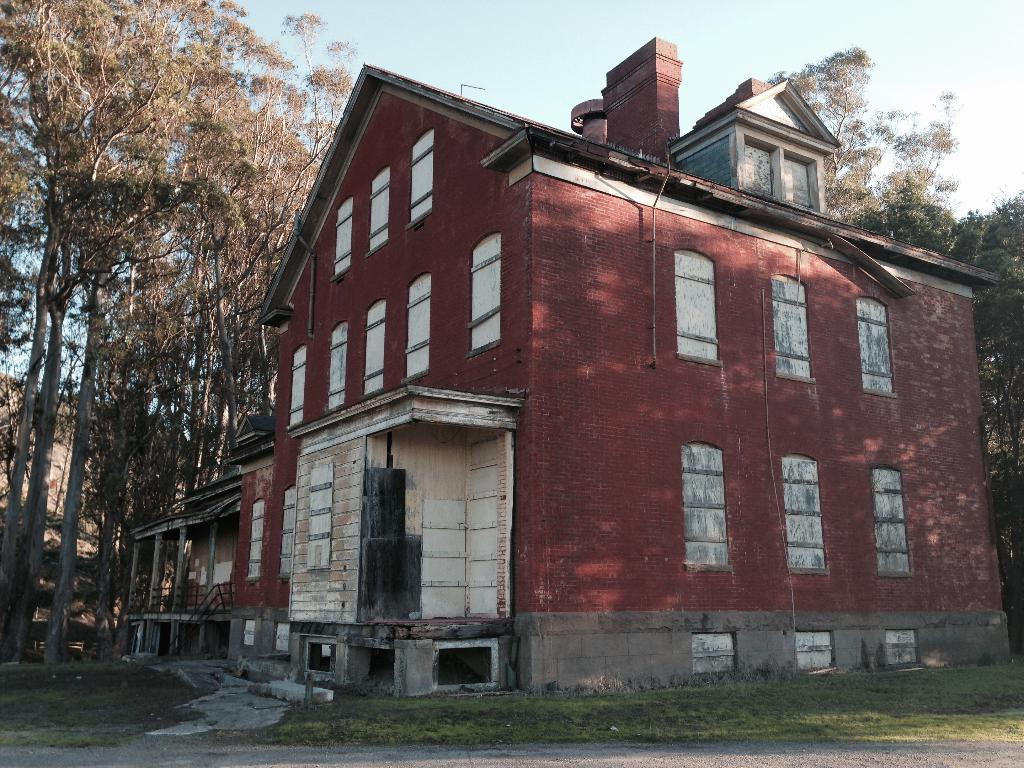What is the main subject in the center of the image? There is a house in the center of the image. What can be seen in the background of the image? There are trees and houses in the background of the image. What is at the bottom of the image? There is a walkway and grass at the bottom of the image. What is visible at the top of the image? The sky is visible at the top of the image. What type of cord is hanging from the roof of the house in the image? There is no cord hanging from the roof of the house in the image. Can you see a tail on any of the trees in the image? There are no tails visible on the trees in the image. 